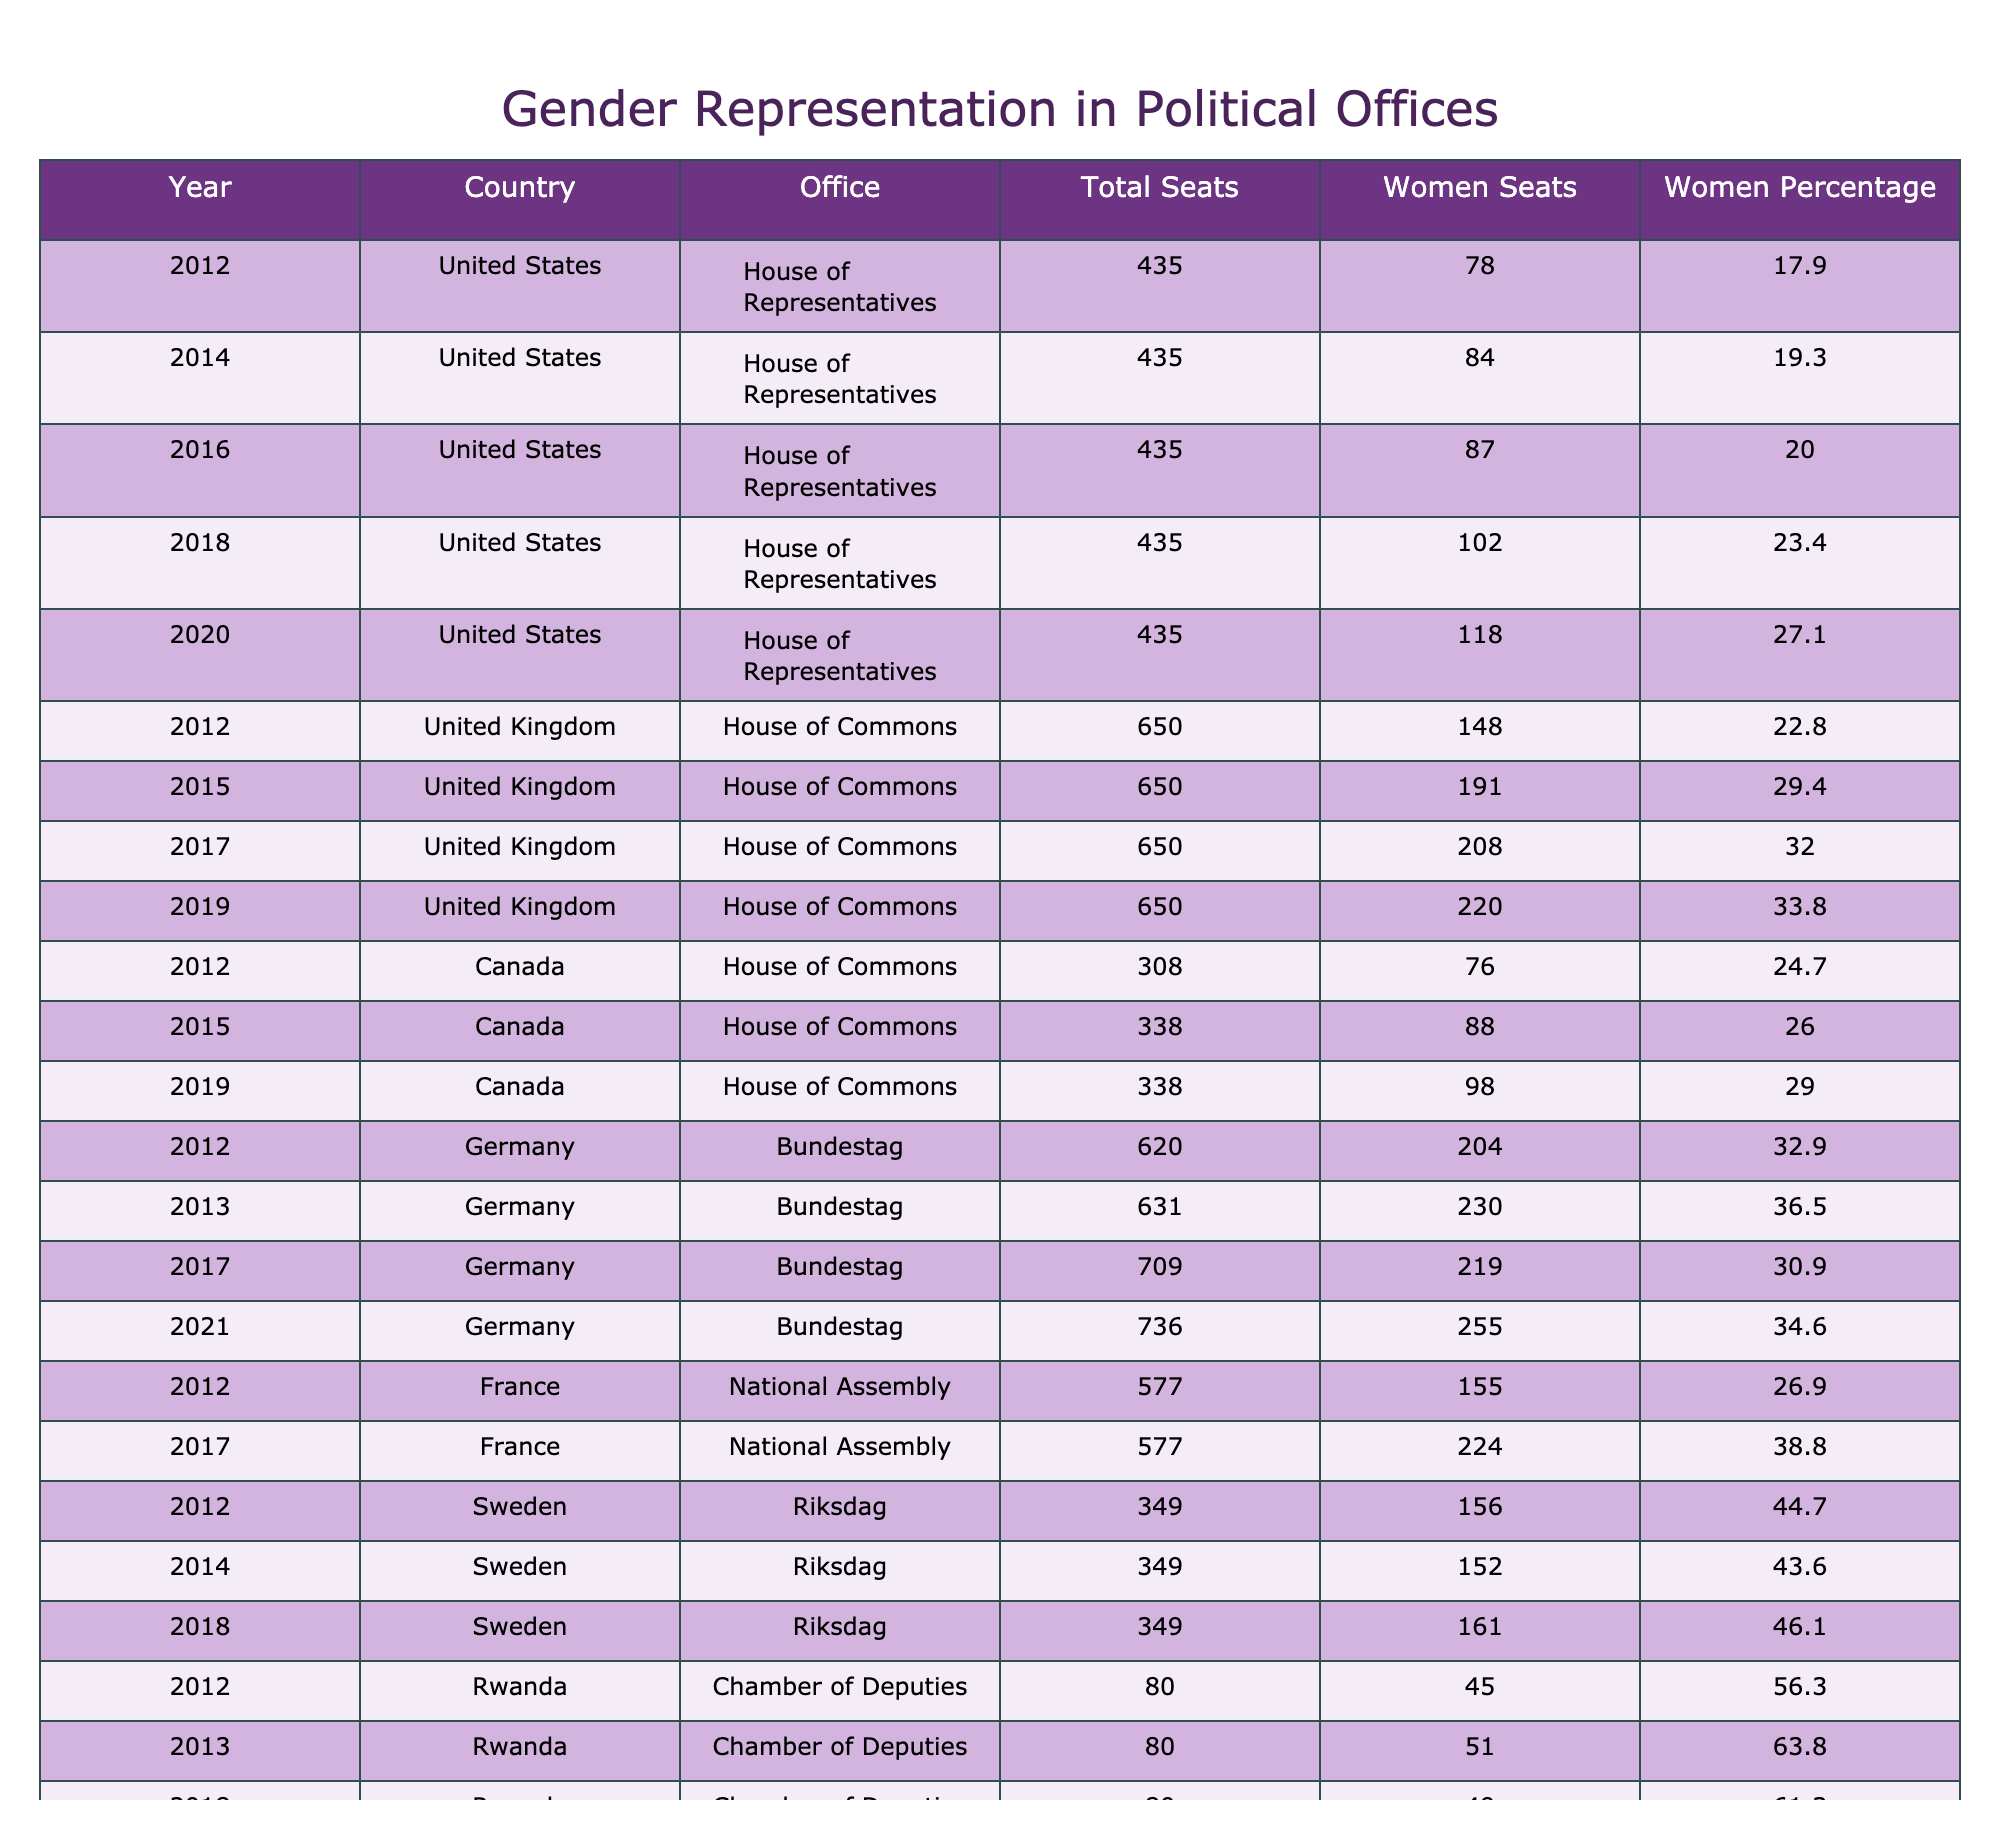What was the percentage of women in the United States House of Representatives in 2020? In the row corresponding to the year 2020 for the United States House of Representatives, the Women Percentage is listed as 27.1.
Answer: 27.1 Which country had the highest percentage of women in its Chamber of Deputies in 2013? In 2013, Rwanda's Chamber of Deputies has a Women Percentage of 63.8, which is higher than the values for other countries in that year.
Answer: Rwanda What year did the United Kingdom House of Commons first exceed 200 women seats? The United Kingdom House of Commons first exceeded 200 women seats in the year 2017, where it reached 208.
Answer: 2017 Calculate the average percentage of women in the Canadian House of Commons over the years available. Looking at the values in the table for Canada (24.7 in 2012, 26.0 in 2015, and 29.0 in 2019), we calculate the total sum as 24.7 + 26.0 + 29.0 = 79.7. With 3 data points, the average is 79.7 / 3 = 26.57.
Answer: 26.57 Did the percentage of women in the German Bundestag ever drop below 30% in the years provided? By examining the percentages for the years listed, we see 32.9, 36.5, 30.9, and 34.6. None of these values drop below 30%, so the answer is no.
Answer: No What was the difference in the number of women seats between the House of Commons in the UK in 2015 and in 2019? In 2015, the number of women seats was 191, and in 2019, it was 220. The difference is calculated as 220 - 191 = 29.
Answer: 29 Which country had the greatest increase in the percentage of women in the House of Commons from 2012 to 2019? For the United Kingdom, the percentage increased from 22.8 (2012) to 33.8 (2019), a difference of 11.0. For Canada, it increased from 24.7 (2012) to 29.0 (2019), a difference of 4.3. The UK had the greatest increase.
Answer: United Kingdom How many total seats were there in Germany's Bundestag in 2021? In the row for Germany's Bundestag in 2021, the Total Seats is listed as 736.
Answer: 736 What was the percentage of women in the Rwandan Chamber of Deputies in 2018, and how does it compare to the percentage in 2013? In 2018, Rwanda's percentage of women in the Chamber of Deputies was 61.3, which is lower than the 63.8 in 2013, indicating a decrease.
Answer: Decrease Was there a year in which the women representation in the United States House of Representatives rose by more than 5% compared to the previous election cycle? The percentage rose from 23.4 in 2018 to 27.1 in 2020, which is an increase of 3.7%, less than 5%. Checking other years shows no increases beyond that threshold.
Answer: No 